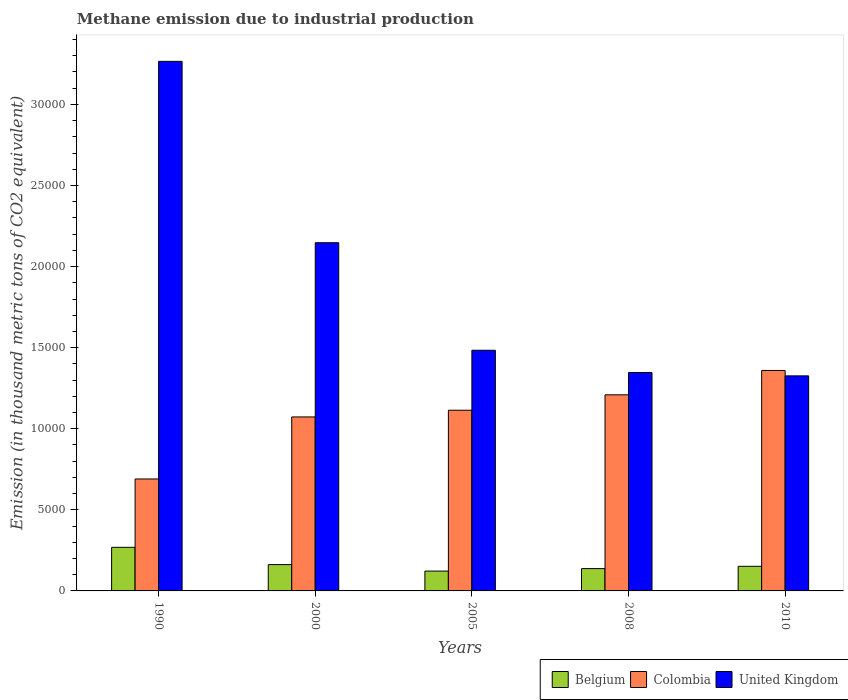How many different coloured bars are there?
Your answer should be compact. 3. How many groups of bars are there?
Your answer should be very brief. 5. Are the number of bars on each tick of the X-axis equal?
Give a very brief answer. Yes. How many bars are there on the 2nd tick from the left?
Your answer should be compact. 3. In how many cases, is the number of bars for a given year not equal to the number of legend labels?
Provide a succinct answer. 0. What is the amount of methane emitted in Colombia in 2010?
Make the answer very short. 1.36e+04. Across all years, what is the maximum amount of methane emitted in Belgium?
Your answer should be compact. 2688.2. Across all years, what is the minimum amount of methane emitted in Belgium?
Make the answer very short. 1222.7. In which year was the amount of methane emitted in Belgium minimum?
Provide a short and direct response. 2005. What is the total amount of methane emitted in United Kingdom in the graph?
Offer a terse response. 9.57e+04. What is the difference between the amount of methane emitted in Colombia in 1990 and that in 2005?
Provide a short and direct response. -4239.3. What is the difference between the amount of methane emitted in Belgium in 2008 and the amount of methane emitted in United Kingdom in 2005?
Offer a terse response. -1.35e+04. What is the average amount of methane emitted in United Kingdom per year?
Your answer should be compact. 1.91e+04. In the year 2010, what is the difference between the amount of methane emitted in Belgium and amount of methane emitted in United Kingdom?
Your response must be concise. -1.17e+04. What is the ratio of the amount of methane emitted in United Kingdom in 2000 to that in 2010?
Provide a succinct answer. 1.62. Is the difference between the amount of methane emitted in Belgium in 1990 and 2010 greater than the difference between the amount of methane emitted in United Kingdom in 1990 and 2010?
Keep it short and to the point. No. What is the difference between the highest and the second highest amount of methane emitted in United Kingdom?
Make the answer very short. 1.12e+04. What is the difference between the highest and the lowest amount of methane emitted in Belgium?
Your answer should be very brief. 1465.5. What does the 2nd bar from the left in 2000 represents?
Offer a very short reply. Colombia. Are all the bars in the graph horizontal?
Your answer should be very brief. No. How many years are there in the graph?
Keep it short and to the point. 5. What is the difference between two consecutive major ticks on the Y-axis?
Give a very brief answer. 5000. Are the values on the major ticks of Y-axis written in scientific E-notation?
Keep it short and to the point. No. Does the graph contain grids?
Ensure brevity in your answer.  No. How many legend labels are there?
Keep it short and to the point. 3. What is the title of the graph?
Offer a terse response. Methane emission due to industrial production. What is the label or title of the X-axis?
Provide a short and direct response. Years. What is the label or title of the Y-axis?
Provide a succinct answer. Emission (in thousand metric tons of CO2 equivalent). What is the Emission (in thousand metric tons of CO2 equivalent) of Belgium in 1990?
Give a very brief answer. 2688.2. What is the Emission (in thousand metric tons of CO2 equivalent) of Colombia in 1990?
Offer a terse response. 6902.6. What is the Emission (in thousand metric tons of CO2 equivalent) of United Kingdom in 1990?
Provide a succinct answer. 3.27e+04. What is the Emission (in thousand metric tons of CO2 equivalent) of Belgium in 2000?
Offer a terse response. 1623. What is the Emission (in thousand metric tons of CO2 equivalent) of Colombia in 2000?
Offer a terse response. 1.07e+04. What is the Emission (in thousand metric tons of CO2 equivalent) in United Kingdom in 2000?
Ensure brevity in your answer.  2.15e+04. What is the Emission (in thousand metric tons of CO2 equivalent) of Belgium in 2005?
Your answer should be very brief. 1222.7. What is the Emission (in thousand metric tons of CO2 equivalent) of Colombia in 2005?
Your answer should be compact. 1.11e+04. What is the Emission (in thousand metric tons of CO2 equivalent) of United Kingdom in 2005?
Your response must be concise. 1.48e+04. What is the Emission (in thousand metric tons of CO2 equivalent) in Belgium in 2008?
Your response must be concise. 1376.4. What is the Emission (in thousand metric tons of CO2 equivalent) of Colombia in 2008?
Your answer should be compact. 1.21e+04. What is the Emission (in thousand metric tons of CO2 equivalent) in United Kingdom in 2008?
Make the answer very short. 1.35e+04. What is the Emission (in thousand metric tons of CO2 equivalent) of Belgium in 2010?
Your answer should be compact. 1518. What is the Emission (in thousand metric tons of CO2 equivalent) of Colombia in 2010?
Make the answer very short. 1.36e+04. What is the Emission (in thousand metric tons of CO2 equivalent) of United Kingdom in 2010?
Keep it short and to the point. 1.33e+04. Across all years, what is the maximum Emission (in thousand metric tons of CO2 equivalent) in Belgium?
Your response must be concise. 2688.2. Across all years, what is the maximum Emission (in thousand metric tons of CO2 equivalent) of Colombia?
Your answer should be very brief. 1.36e+04. Across all years, what is the maximum Emission (in thousand metric tons of CO2 equivalent) of United Kingdom?
Provide a short and direct response. 3.27e+04. Across all years, what is the minimum Emission (in thousand metric tons of CO2 equivalent) of Belgium?
Ensure brevity in your answer.  1222.7. Across all years, what is the minimum Emission (in thousand metric tons of CO2 equivalent) of Colombia?
Offer a very short reply. 6902.6. Across all years, what is the minimum Emission (in thousand metric tons of CO2 equivalent) of United Kingdom?
Offer a terse response. 1.33e+04. What is the total Emission (in thousand metric tons of CO2 equivalent) of Belgium in the graph?
Give a very brief answer. 8428.3. What is the total Emission (in thousand metric tons of CO2 equivalent) of Colombia in the graph?
Your answer should be very brief. 5.45e+04. What is the total Emission (in thousand metric tons of CO2 equivalent) in United Kingdom in the graph?
Your response must be concise. 9.57e+04. What is the difference between the Emission (in thousand metric tons of CO2 equivalent) in Belgium in 1990 and that in 2000?
Offer a terse response. 1065.2. What is the difference between the Emission (in thousand metric tons of CO2 equivalent) of Colombia in 1990 and that in 2000?
Make the answer very short. -3825.6. What is the difference between the Emission (in thousand metric tons of CO2 equivalent) in United Kingdom in 1990 and that in 2000?
Provide a short and direct response. 1.12e+04. What is the difference between the Emission (in thousand metric tons of CO2 equivalent) in Belgium in 1990 and that in 2005?
Your response must be concise. 1465.5. What is the difference between the Emission (in thousand metric tons of CO2 equivalent) in Colombia in 1990 and that in 2005?
Offer a very short reply. -4239.3. What is the difference between the Emission (in thousand metric tons of CO2 equivalent) in United Kingdom in 1990 and that in 2005?
Your response must be concise. 1.78e+04. What is the difference between the Emission (in thousand metric tons of CO2 equivalent) in Belgium in 1990 and that in 2008?
Provide a succinct answer. 1311.8. What is the difference between the Emission (in thousand metric tons of CO2 equivalent) in Colombia in 1990 and that in 2008?
Keep it short and to the point. -5189.3. What is the difference between the Emission (in thousand metric tons of CO2 equivalent) in United Kingdom in 1990 and that in 2008?
Your answer should be very brief. 1.92e+04. What is the difference between the Emission (in thousand metric tons of CO2 equivalent) of Belgium in 1990 and that in 2010?
Offer a terse response. 1170.2. What is the difference between the Emission (in thousand metric tons of CO2 equivalent) of Colombia in 1990 and that in 2010?
Provide a short and direct response. -6690.9. What is the difference between the Emission (in thousand metric tons of CO2 equivalent) in United Kingdom in 1990 and that in 2010?
Offer a terse response. 1.94e+04. What is the difference between the Emission (in thousand metric tons of CO2 equivalent) in Belgium in 2000 and that in 2005?
Offer a very short reply. 400.3. What is the difference between the Emission (in thousand metric tons of CO2 equivalent) in Colombia in 2000 and that in 2005?
Offer a terse response. -413.7. What is the difference between the Emission (in thousand metric tons of CO2 equivalent) of United Kingdom in 2000 and that in 2005?
Keep it short and to the point. 6631. What is the difference between the Emission (in thousand metric tons of CO2 equivalent) in Belgium in 2000 and that in 2008?
Your answer should be very brief. 246.6. What is the difference between the Emission (in thousand metric tons of CO2 equivalent) in Colombia in 2000 and that in 2008?
Give a very brief answer. -1363.7. What is the difference between the Emission (in thousand metric tons of CO2 equivalent) in United Kingdom in 2000 and that in 2008?
Your answer should be very brief. 8001.7. What is the difference between the Emission (in thousand metric tons of CO2 equivalent) of Belgium in 2000 and that in 2010?
Provide a short and direct response. 105. What is the difference between the Emission (in thousand metric tons of CO2 equivalent) in Colombia in 2000 and that in 2010?
Make the answer very short. -2865.3. What is the difference between the Emission (in thousand metric tons of CO2 equivalent) in United Kingdom in 2000 and that in 2010?
Your answer should be compact. 8210. What is the difference between the Emission (in thousand metric tons of CO2 equivalent) of Belgium in 2005 and that in 2008?
Your answer should be compact. -153.7. What is the difference between the Emission (in thousand metric tons of CO2 equivalent) in Colombia in 2005 and that in 2008?
Your answer should be very brief. -950. What is the difference between the Emission (in thousand metric tons of CO2 equivalent) in United Kingdom in 2005 and that in 2008?
Keep it short and to the point. 1370.7. What is the difference between the Emission (in thousand metric tons of CO2 equivalent) in Belgium in 2005 and that in 2010?
Provide a succinct answer. -295.3. What is the difference between the Emission (in thousand metric tons of CO2 equivalent) of Colombia in 2005 and that in 2010?
Offer a terse response. -2451.6. What is the difference between the Emission (in thousand metric tons of CO2 equivalent) of United Kingdom in 2005 and that in 2010?
Keep it short and to the point. 1579. What is the difference between the Emission (in thousand metric tons of CO2 equivalent) of Belgium in 2008 and that in 2010?
Keep it short and to the point. -141.6. What is the difference between the Emission (in thousand metric tons of CO2 equivalent) in Colombia in 2008 and that in 2010?
Make the answer very short. -1501.6. What is the difference between the Emission (in thousand metric tons of CO2 equivalent) in United Kingdom in 2008 and that in 2010?
Provide a short and direct response. 208.3. What is the difference between the Emission (in thousand metric tons of CO2 equivalent) of Belgium in 1990 and the Emission (in thousand metric tons of CO2 equivalent) of Colombia in 2000?
Ensure brevity in your answer.  -8040. What is the difference between the Emission (in thousand metric tons of CO2 equivalent) of Belgium in 1990 and the Emission (in thousand metric tons of CO2 equivalent) of United Kingdom in 2000?
Your answer should be very brief. -1.88e+04. What is the difference between the Emission (in thousand metric tons of CO2 equivalent) of Colombia in 1990 and the Emission (in thousand metric tons of CO2 equivalent) of United Kingdom in 2000?
Make the answer very short. -1.46e+04. What is the difference between the Emission (in thousand metric tons of CO2 equivalent) of Belgium in 1990 and the Emission (in thousand metric tons of CO2 equivalent) of Colombia in 2005?
Provide a succinct answer. -8453.7. What is the difference between the Emission (in thousand metric tons of CO2 equivalent) in Belgium in 1990 and the Emission (in thousand metric tons of CO2 equivalent) in United Kingdom in 2005?
Provide a short and direct response. -1.22e+04. What is the difference between the Emission (in thousand metric tons of CO2 equivalent) in Colombia in 1990 and the Emission (in thousand metric tons of CO2 equivalent) in United Kingdom in 2005?
Provide a short and direct response. -7937.1. What is the difference between the Emission (in thousand metric tons of CO2 equivalent) in Belgium in 1990 and the Emission (in thousand metric tons of CO2 equivalent) in Colombia in 2008?
Ensure brevity in your answer.  -9403.7. What is the difference between the Emission (in thousand metric tons of CO2 equivalent) of Belgium in 1990 and the Emission (in thousand metric tons of CO2 equivalent) of United Kingdom in 2008?
Ensure brevity in your answer.  -1.08e+04. What is the difference between the Emission (in thousand metric tons of CO2 equivalent) of Colombia in 1990 and the Emission (in thousand metric tons of CO2 equivalent) of United Kingdom in 2008?
Your response must be concise. -6566.4. What is the difference between the Emission (in thousand metric tons of CO2 equivalent) of Belgium in 1990 and the Emission (in thousand metric tons of CO2 equivalent) of Colombia in 2010?
Offer a terse response. -1.09e+04. What is the difference between the Emission (in thousand metric tons of CO2 equivalent) in Belgium in 1990 and the Emission (in thousand metric tons of CO2 equivalent) in United Kingdom in 2010?
Provide a succinct answer. -1.06e+04. What is the difference between the Emission (in thousand metric tons of CO2 equivalent) in Colombia in 1990 and the Emission (in thousand metric tons of CO2 equivalent) in United Kingdom in 2010?
Provide a short and direct response. -6358.1. What is the difference between the Emission (in thousand metric tons of CO2 equivalent) in Belgium in 2000 and the Emission (in thousand metric tons of CO2 equivalent) in Colombia in 2005?
Ensure brevity in your answer.  -9518.9. What is the difference between the Emission (in thousand metric tons of CO2 equivalent) in Belgium in 2000 and the Emission (in thousand metric tons of CO2 equivalent) in United Kingdom in 2005?
Keep it short and to the point. -1.32e+04. What is the difference between the Emission (in thousand metric tons of CO2 equivalent) of Colombia in 2000 and the Emission (in thousand metric tons of CO2 equivalent) of United Kingdom in 2005?
Keep it short and to the point. -4111.5. What is the difference between the Emission (in thousand metric tons of CO2 equivalent) of Belgium in 2000 and the Emission (in thousand metric tons of CO2 equivalent) of Colombia in 2008?
Offer a terse response. -1.05e+04. What is the difference between the Emission (in thousand metric tons of CO2 equivalent) of Belgium in 2000 and the Emission (in thousand metric tons of CO2 equivalent) of United Kingdom in 2008?
Your response must be concise. -1.18e+04. What is the difference between the Emission (in thousand metric tons of CO2 equivalent) in Colombia in 2000 and the Emission (in thousand metric tons of CO2 equivalent) in United Kingdom in 2008?
Keep it short and to the point. -2740.8. What is the difference between the Emission (in thousand metric tons of CO2 equivalent) in Belgium in 2000 and the Emission (in thousand metric tons of CO2 equivalent) in Colombia in 2010?
Offer a terse response. -1.20e+04. What is the difference between the Emission (in thousand metric tons of CO2 equivalent) in Belgium in 2000 and the Emission (in thousand metric tons of CO2 equivalent) in United Kingdom in 2010?
Your response must be concise. -1.16e+04. What is the difference between the Emission (in thousand metric tons of CO2 equivalent) in Colombia in 2000 and the Emission (in thousand metric tons of CO2 equivalent) in United Kingdom in 2010?
Provide a succinct answer. -2532.5. What is the difference between the Emission (in thousand metric tons of CO2 equivalent) of Belgium in 2005 and the Emission (in thousand metric tons of CO2 equivalent) of Colombia in 2008?
Give a very brief answer. -1.09e+04. What is the difference between the Emission (in thousand metric tons of CO2 equivalent) in Belgium in 2005 and the Emission (in thousand metric tons of CO2 equivalent) in United Kingdom in 2008?
Provide a succinct answer. -1.22e+04. What is the difference between the Emission (in thousand metric tons of CO2 equivalent) in Colombia in 2005 and the Emission (in thousand metric tons of CO2 equivalent) in United Kingdom in 2008?
Your answer should be very brief. -2327.1. What is the difference between the Emission (in thousand metric tons of CO2 equivalent) in Belgium in 2005 and the Emission (in thousand metric tons of CO2 equivalent) in Colombia in 2010?
Your response must be concise. -1.24e+04. What is the difference between the Emission (in thousand metric tons of CO2 equivalent) of Belgium in 2005 and the Emission (in thousand metric tons of CO2 equivalent) of United Kingdom in 2010?
Your response must be concise. -1.20e+04. What is the difference between the Emission (in thousand metric tons of CO2 equivalent) of Colombia in 2005 and the Emission (in thousand metric tons of CO2 equivalent) of United Kingdom in 2010?
Your answer should be very brief. -2118.8. What is the difference between the Emission (in thousand metric tons of CO2 equivalent) of Belgium in 2008 and the Emission (in thousand metric tons of CO2 equivalent) of Colombia in 2010?
Provide a short and direct response. -1.22e+04. What is the difference between the Emission (in thousand metric tons of CO2 equivalent) of Belgium in 2008 and the Emission (in thousand metric tons of CO2 equivalent) of United Kingdom in 2010?
Offer a very short reply. -1.19e+04. What is the difference between the Emission (in thousand metric tons of CO2 equivalent) of Colombia in 2008 and the Emission (in thousand metric tons of CO2 equivalent) of United Kingdom in 2010?
Offer a terse response. -1168.8. What is the average Emission (in thousand metric tons of CO2 equivalent) of Belgium per year?
Ensure brevity in your answer.  1685.66. What is the average Emission (in thousand metric tons of CO2 equivalent) in Colombia per year?
Provide a succinct answer. 1.09e+04. What is the average Emission (in thousand metric tons of CO2 equivalent) of United Kingdom per year?
Provide a succinct answer. 1.91e+04. In the year 1990, what is the difference between the Emission (in thousand metric tons of CO2 equivalent) of Belgium and Emission (in thousand metric tons of CO2 equivalent) of Colombia?
Provide a succinct answer. -4214.4. In the year 1990, what is the difference between the Emission (in thousand metric tons of CO2 equivalent) in Belgium and Emission (in thousand metric tons of CO2 equivalent) in United Kingdom?
Make the answer very short. -3.00e+04. In the year 1990, what is the difference between the Emission (in thousand metric tons of CO2 equivalent) in Colombia and Emission (in thousand metric tons of CO2 equivalent) in United Kingdom?
Provide a short and direct response. -2.58e+04. In the year 2000, what is the difference between the Emission (in thousand metric tons of CO2 equivalent) of Belgium and Emission (in thousand metric tons of CO2 equivalent) of Colombia?
Provide a short and direct response. -9105.2. In the year 2000, what is the difference between the Emission (in thousand metric tons of CO2 equivalent) in Belgium and Emission (in thousand metric tons of CO2 equivalent) in United Kingdom?
Ensure brevity in your answer.  -1.98e+04. In the year 2000, what is the difference between the Emission (in thousand metric tons of CO2 equivalent) of Colombia and Emission (in thousand metric tons of CO2 equivalent) of United Kingdom?
Your response must be concise. -1.07e+04. In the year 2005, what is the difference between the Emission (in thousand metric tons of CO2 equivalent) in Belgium and Emission (in thousand metric tons of CO2 equivalent) in Colombia?
Your answer should be very brief. -9919.2. In the year 2005, what is the difference between the Emission (in thousand metric tons of CO2 equivalent) in Belgium and Emission (in thousand metric tons of CO2 equivalent) in United Kingdom?
Ensure brevity in your answer.  -1.36e+04. In the year 2005, what is the difference between the Emission (in thousand metric tons of CO2 equivalent) of Colombia and Emission (in thousand metric tons of CO2 equivalent) of United Kingdom?
Make the answer very short. -3697.8. In the year 2008, what is the difference between the Emission (in thousand metric tons of CO2 equivalent) in Belgium and Emission (in thousand metric tons of CO2 equivalent) in Colombia?
Offer a terse response. -1.07e+04. In the year 2008, what is the difference between the Emission (in thousand metric tons of CO2 equivalent) of Belgium and Emission (in thousand metric tons of CO2 equivalent) of United Kingdom?
Ensure brevity in your answer.  -1.21e+04. In the year 2008, what is the difference between the Emission (in thousand metric tons of CO2 equivalent) of Colombia and Emission (in thousand metric tons of CO2 equivalent) of United Kingdom?
Your answer should be compact. -1377.1. In the year 2010, what is the difference between the Emission (in thousand metric tons of CO2 equivalent) of Belgium and Emission (in thousand metric tons of CO2 equivalent) of Colombia?
Your answer should be very brief. -1.21e+04. In the year 2010, what is the difference between the Emission (in thousand metric tons of CO2 equivalent) in Belgium and Emission (in thousand metric tons of CO2 equivalent) in United Kingdom?
Provide a succinct answer. -1.17e+04. In the year 2010, what is the difference between the Emission (in thousand metric tons of CO2 equivalent) of Colombia and Emission (in thousand metric tons of CO2 equivalent) of United Kingdom?
Your response must be concise. 332.8. What is the ratio of the Emission (in thousand metric tons of CO2 equivalent) in Belgium in 1990 to that in 2000?
Offer a very short reply. 1.66. What is the ratio of the Emission (in thousand metric tons of CO2 equivalent) of Colombia in 1990 to that in 2000?
Offer a terse response. 0.64. What is the ratio of the Emission (in thousand metric tons of CO2 equivalent) in United Kingdom in 1990 to that in 2000?
Keep it short and to the point. 1.52. What is the ratio of the Emission (in thousand metric tons of CO2 equivalent) of Belgium in 1990 to that in 2005?
Ensure brevity in your answer.  2.2. What is the ratio of the Emission (in thousand metric tons of CO2 equivalent) in Colombia in 1990 to that in 2005?
Provide a succinct answer. 0.62. What is the ratio of the Emission (in thousand metric tons of CO2 equivalent) of United Kingdom in 1990 to that in 2005?
Provide a succinct answer. 2.2. What is the ratio of the Emission (in thousand metric tons of CO2 equivalent) in Belgium in 1990 to that in 2008?
Offer a terse response. 1.95. What is the ratio of the Emission (in thousand metric tons of CO2 equivalent) of Colombia in 1990 to that in 2008?
Ensure brevity in your answer.  0.57. What is the ratio of the Emission (in thousand metric tons of CO2 equivalent) in United Kingdom in 1990 to that in 2008?
Offer a very short reply. 2.42. What is the ratio of the Emission (in thousand metric tons of CO2 equivalent) of Belgium in 1990 to that in 2010?
Your answer should be compact. 1.77. What is the ratio of the Emission (in thousand metric tons of CO2 equivalent) in Colombia in 1990 to that in 2010?
Offer a terse response. 0.51. What is the ratio of the Emission (in thousand metric tons of CO2 equivalent) of United Kingdom in 1990 to that in 2010?
Ensure brevity in your answer.  2.46. What is the ratio of the Emission (in thousand metric tons of CO2 equivalent) of Belgium in 2000 to that in 2005?
Ensure brevity in your answer.  1.33. What is the ratio of the Emission (in thousand metric tons of CO2 equivalent) of Colombia in 2000 to that in 2005?
Keep it short and to the point. 0.96. What is the ratio of the Emission (in thousand metric tons of CO2 equivalent) in United Kingdom in 2000 to that in 2005?
Your answer should be compact. 1.45. What is the ratio of the Emission (in thousand metric tons of CO2 equivalent) in Belgium in 2000 to that in 2008?
Your answer should be compact. 1.18. What is the ratio of the Emission (in thousand metric tons of CO2 equivalent) in Colombia in 2000 to that in 2008?
Offer a very short reply. 0.89. What is the ratio of the Emission (in thousand metric tons of CO2 equivalent) of United Kingdom in 2000 to that in 2008?
Your answer should be very brief. 1.59. What is the ratio of the Emission (in thousand metric tons of CO2 equivalent) in Belgium in 2000 to that in 2010?
Provide a succinct answer. 1.07. What is the ratio of the Emission (in thousand metric tons of CO2 equivalent) of Colombia in 2000 to that in 2010?
Your answer should be compact. 0.79. What is the ratio of the Emission (in thousand metric tons of CO2 equivalent) in United Kingdom in 2000 to that in 2010?
Offer a very short reply. 1.62. What is the ratio of the Emission (in thousand metric tons of CO2 equivalent) of Belgium in 2005 to that in 2008?
Keep it short and to the point. 0.89. What is the ratio of the Emission (in thousand metric tons of CO2 equivalent) in Colombia in 2005 to that in 2008?
Provide a succinct answer. 0.92. What is the ratio of the Emission (in thousand metric tons of CO2 equivalent) of United Kingdom in 2005 to that in 2008?
Make the answer very short. 1.1. What is the ratio of the Emission (in thousand metric tons of CO2 equivalent) in Belgium in 2005 to that in 2010?
Your response must be concise. 0.81. What is the ratio of the Emission (in thousand metric tons of CO2 equivalent) in Colombia in 2005 to that in 2010?
Give a very brief answer. 0.82. What is the ratio of the Emission (in thousand metric tons of CO2 equivalent) of United Kingdom in 2005 to that in 2010?
Provide a short and direct response. 1.12. What is the ratio of the Emission (in thousand metric tons of CO2 equivalent) of Belgium in 2008 to that in 2010?
Keep it short and to the point. 0.91. What is the ratio of the Emission (in thousand metric tons of CO2 equivalent) in Colombia in 2008 to that in 2010?
Ensure brevity in your answer.  0.89. What is the ratio of the Emission (in thousand metric tons of CO2 equivalent) of United Kingdom in 2008 to that in 2010?
Keep it short and to the point. 1.02. What is the difference between the highest and the second highest Emission (in thousand metric tons of CO2 equivalent) in Belgium?
Ensure brevity in your answer.  1065.2. What is the difference between the highest and the second highest Emission (in thousand metric tons of CO2 equivalent) in Colombia?
Your answer should be compact. 1501.6. What is the difference between the highest and the second highest Emission (in thousand metric tons of CO2 equivalent) of United Kingdom?
Your response must be concise. 1.12e+04. What is the difference between the highest and the lowest Emission (in thousand metric tons of CO2 equivalent) of Belgium?
Offer a very short reply. 1465.5. What is the difference between the highest and the lowest Emission (in thousand metric tons of CO2 equivalent) in Colombia?
Your answer should be compact. 6690.9. What is the difference between the highest and the lowest Emission (in thousand metric tons of CO2 equivalent) of United Kingdom?
Provide a succinct answer. 1.94e+04. 